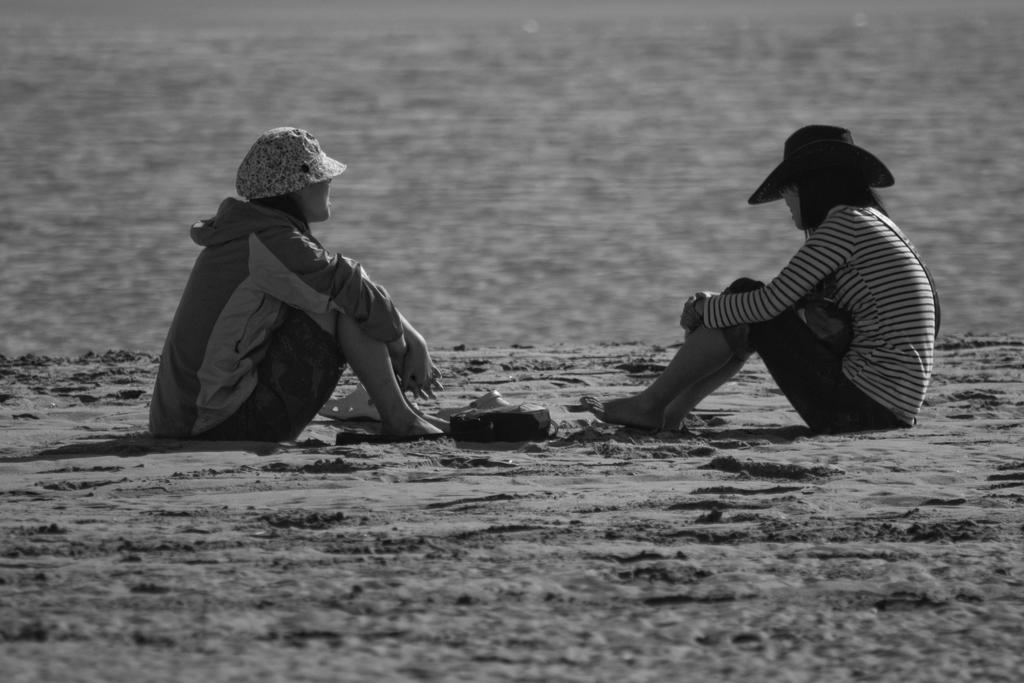What is the color scheme of the image? The image is black and white. How many people are in the image? There are two women in the image. What type of surface are the women sitting on? The women are sitting on sand. What type of footwear can be seen in the image? There are slippers visible in the image. What type of copper object can be seen in the image? There is no copper object present in the image. How many zebras are visible in the image? There are no zebras visible in the image. 